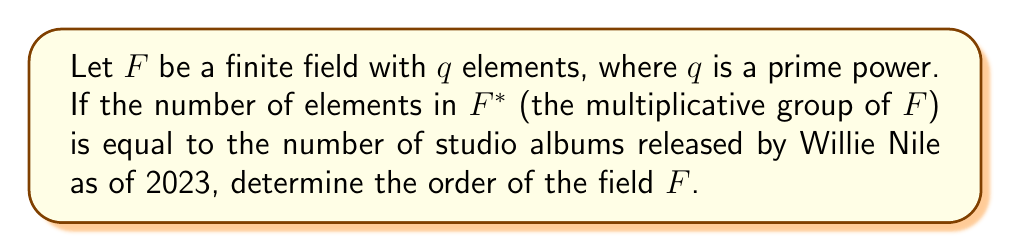Teach me how to tackle this problem. 1. First, we need to know how many studio albums Willie Nile has released as of 2023. As an avid fan, you would know that Willie Nile has released 14 studio albums.

2. In a finite field $F$ with $q$ elements, the multiplicative group $F^*$ consists of all non-zero elements. Therefore, $|F^*| = q - 1$.

3. Given the information in the question, we can set up the equation:
   $q - 1 = 14$

4. Solving for $q$:
   $q = 14 + 1 = 15$

5. However, we need to check if 15 is a valid order for a finite field. The order of a finite field must be a prime power.

6. 15 can be factored as $3 \times 5$, which is the product of two distinct primes.

7. Therefore, 15 is not a valid order for a finite field.

8. The next prime power greater than 15 is $2^4 = 16$.

9. Thus, the smallest possible order for the field $F$ that satisfies the condition is 16.
Answer: 16 